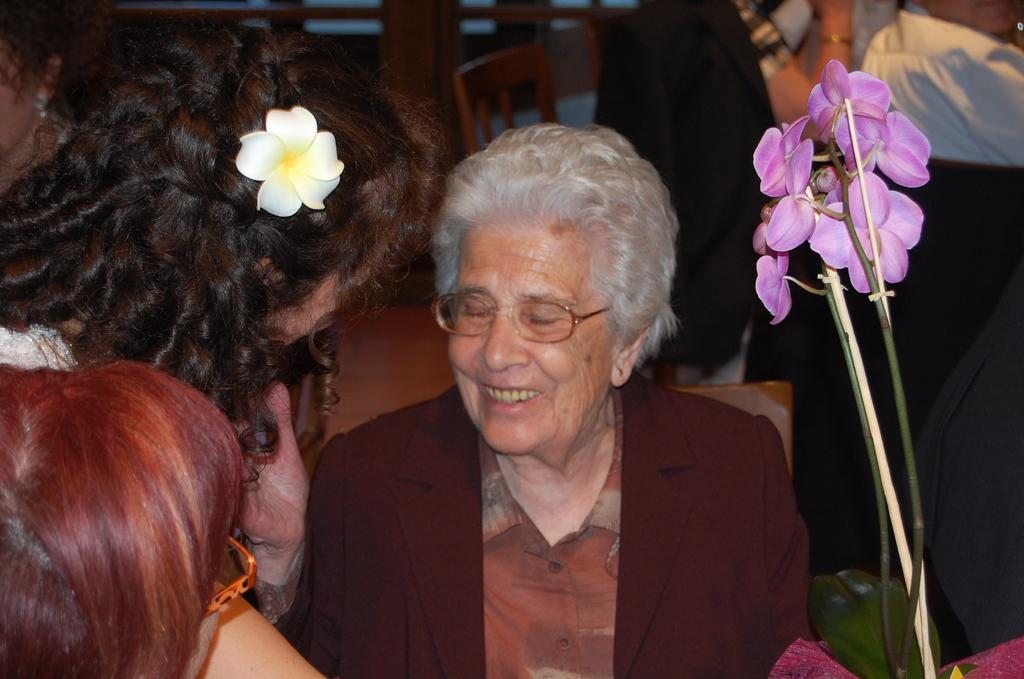Please provide a concise description of this image. In this image there is an old woman sitting in the chair. In front of her there is a table on which there is a flower vase with the flowers. On the left side there are two girls. The girl at the top is having a white flower in her hair. In the background there are chairs. On the right side there are few other people standing on the floor. 